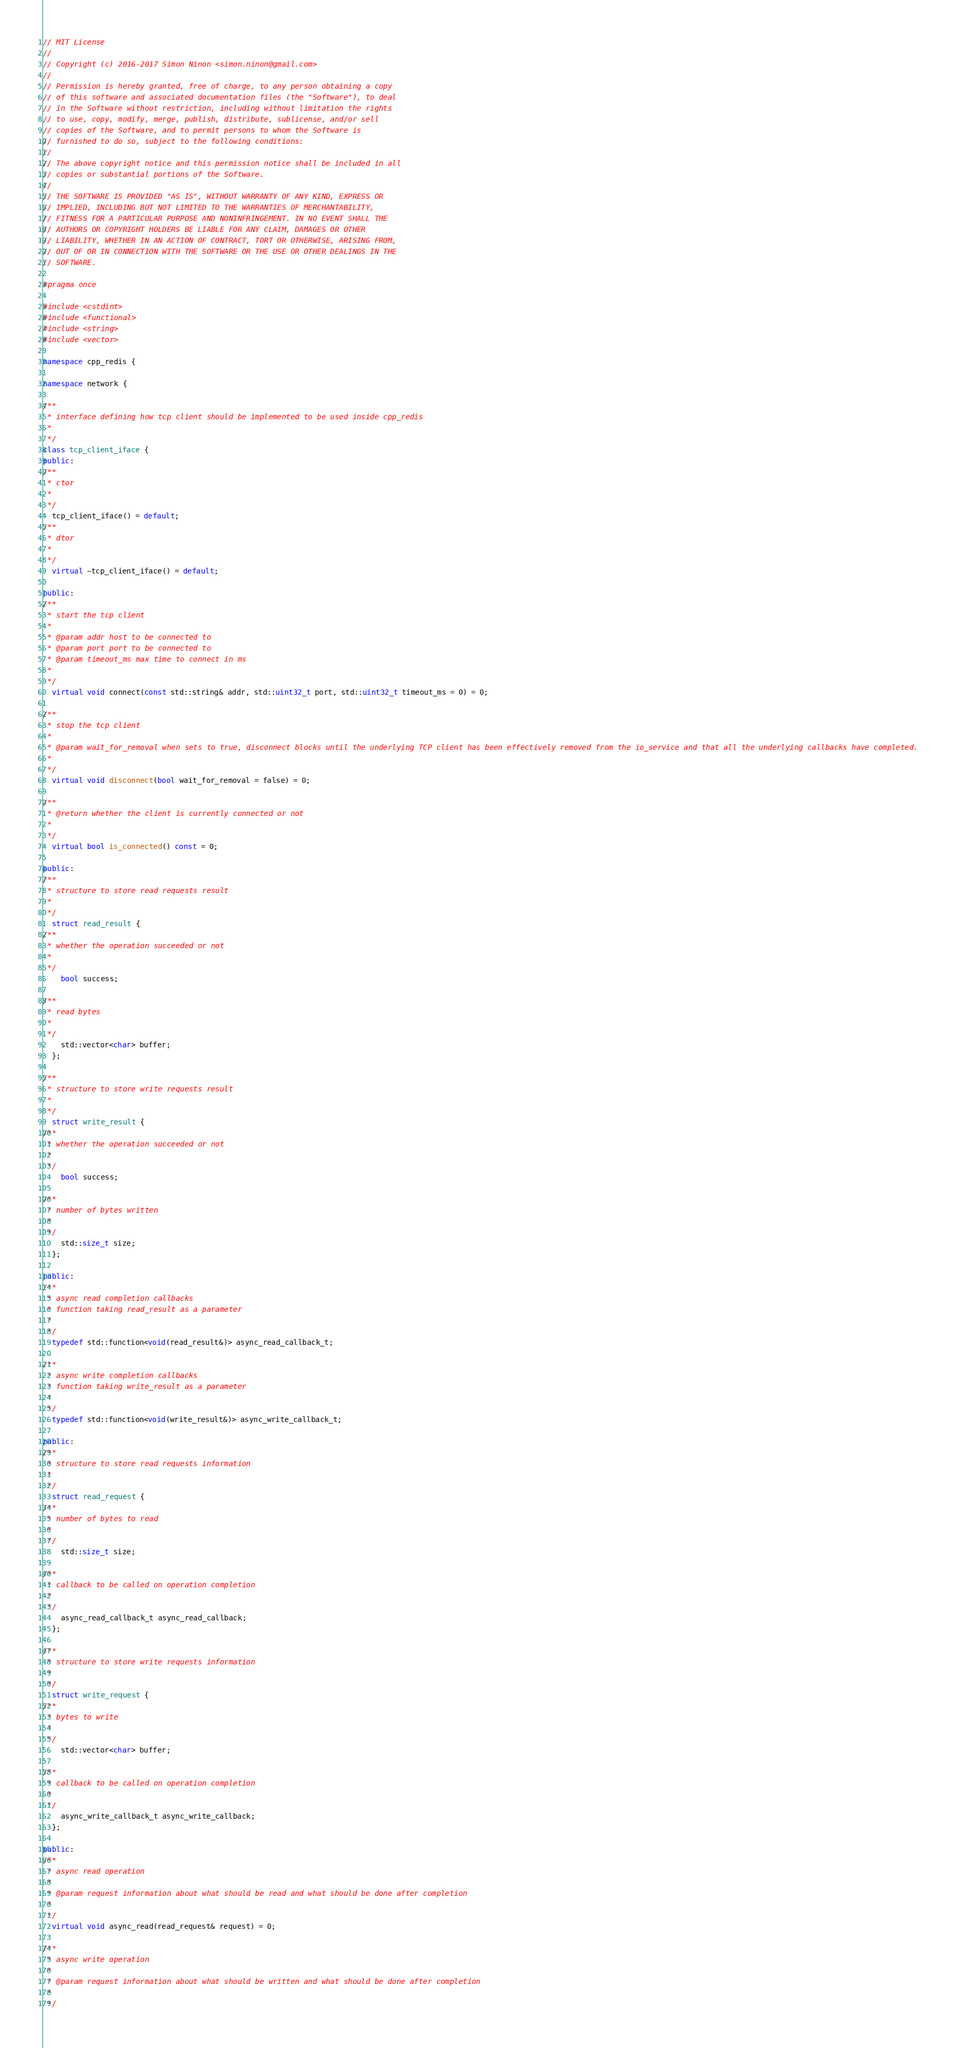<code> <loc_0><loc_0><loc_500><loc_500><_C++_>// MIT License
//
// Copyright (c) 2016-2017 Simon Ninon <simon.ninon@gmail.com>
//
// Permission is hereby granted, free of charge, to any person obtaining a copy
// of this software and associated documentation files (the "Software"), to deal
// in the Software without restriction, including without limitation the rights
// to use, copy, modify, merge, publish, distribute, sublicense, and/or sell
// copies of the Software, and to permit persons to whom the Software is
// furnished to do so, subject to the following conditions:
//
// The above copyright notice and this permission notice shall be included in all
// copies or substantial portions of the Software.
//
// THE SOFTWARE IS PROVIDED "AS IS", WITHOUT WARRANTY OF ANY KIND, EXPRESS OR
// IMPLIED, INCLUDING BUT NOT LIMITED TO THE WARRANTIES OF MERCHANTABILITY,
// FITNESS FOR A PARTICULAR PURPOSE AND NONINFRINGEMENT. IN NO EVENT SHALL THE
// AUTHORS OR COPYRIGHT HOLDERS BE LIABLE FOR ANY CLAIM, DAMAGES OR OTHER
// LIABILITY, WHETHER IN AN ACTION OF CONTRACT, TORT OR OTHERWISE, ARISING FROM,
// OUT OF OR IN CONNECTION WITH THE SOFTWARE OR THE USE OR OTHER DEALINGS IN THE
// SOFTWARE.

#pragma once

#include <cstdint>
#include <functional>
#include <string>
#include <vector>

namespace cpp_redis {

namespace network {

/**
 * interface defining how tcp client should be implemented to be used inside cpp_redis
 *
 */
class tcp_client_iface {
public:
/**
 * ctor
 *
 */
  tcp_client_iface() = default;
/**
 * dtor
 *
 */
  virtual ~tcp_client_iface() = default;

public:
/**
 * start the tcp client
 *
 * @param addr host to be connected to
 * @param port port to be connected to
 * @param timeout_ms max time to connect in ms
 *
 */
  virtual void connect(const std::string& addr, std::uint32_t port, std::uint32_t timeout_ms = 0) = 0;

/**
 * stop the tcp client
 *
 * @param wait_for_removal when sets to true, disconnect blocks until the underlying TCP client has been effectively removed from the io_service and that all the underlying callbacks have completed.
 *
 */
  virtual void disconnect(bool wait_for_removal = false) = 0;

/**
 * @return whether the client is currently connected or not
 *
 */
  virtual bool is_connected() const = 0;

public:
/**
 * structure to store read requests result
 *
 */
  struct read_result {
/**
 * whether the operation succeeded or not
 *
 */
    bool success;

/**
 * read bytes
 *
 */
    std::vector<char> buffer;
  };

/**
 * structure to store write requests result
 *
 */
  struct write_result {
/**
 * whether the operation succeeded or not
 *
 */
    bool success;

/**
 * number of bytes written
 *
 */
    std::size_t size;
  };

public:
/**
 * async read completion callbacks
 * function taking read_result as a parameter
 *
 */
  typedef std::function<void(read_result&)> async_read_callback_t;

/**
 * async write completion callbacks
 * function taking write_result as a parameter
 *
 */
  typedef std::function<void(write_result&)> async_write_callback_t;

public:
/**
 * structure to store read requests information
 *
 */
  struct read_request {
/**
 * number of bytes to read
 *
 */
    std::size_t size;

/**
 * callback to be called on operation completion
 *
 */
    async_read_callback_t async_read_callback;
  };

/**
 * structure to store write requests information
 *
 */
  struct write_request {
/**
 * bytes to write
 *
 */
    std::vector<char> buffer;

/**
 * callback to be called on operation completion
 *
 */
    async_write_callback_t async_write_callback;
  };

public:
/**
 * async read operation
 *
 * @param request information about what should be read and what should be done after completion
 *
 */
  virtual void async_read(read_request& request) = 0;

/**
 * async write operation
 *
 * @param request information about what should be written and what should be done after completion
 *
 */</code> 